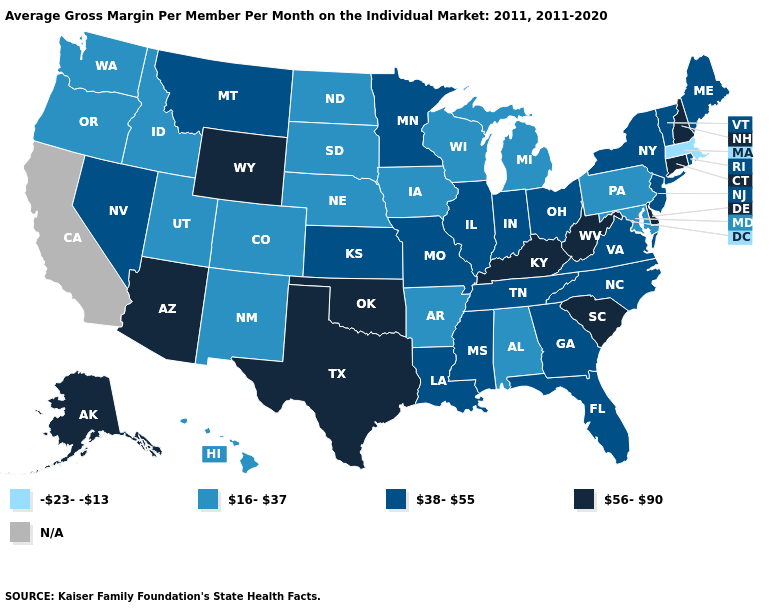Among the states that border West Virginia , does Pennsylvania have the highest value?
Short answer required. No. Among the states that border Washington , which have the lowest value?
Be succinct. Idaho, Oregon. Name the states that have a value in the range N/A?
Answer briefly. California. Name the states that have a value in the range -23--13?
Concise answer only. Massachusetts. Name the states that have a value in the range 56-90?
Answer briefly. Alaska, Arizona, Connecticut, Delaware, Kentucky, New Hampshire, Oklahoma, South Carolina, Texas, West Virginia, Wyoming. What is the lowest value in the MidWest?
Concise answer only. 16-37. Name the states that have a value in the range 38-55?
Concise answer only. Florida, Georgia, Illinois, Indiana, Kansas, Louisiana, Maine, Minnesota, Mississippi, Missouri, Montana, Nevada, New Jersey, New York, North Carolina, Ohio, Rhode Island, Tennessee, Vermont, Virginia. What is the value of Tennessee?
Write a very short answer. 38-55. Name the states that have a value in the range 16-37?
Short answer required. Alabama, Arkansas, Colorado, Hawaii, Idaho, Iowa, Maryland, Michigan, Nebraska, New Mexico, North Dakota, Oregon, Pennsylvania, South Dakota, Utah, Washington, Wisconsin. Does the first symbol in the legend represent the smallest category?
Write a very short answer. Yes. Among the states that border Colorado , which have the lowest value?
Give a very brief answer. Nebraska, New Mexico, Utah. Is the legend a continuous bar?
Be succinct. No. Does Colorado have the lowest value in the USA?
Answer briefly. No. 